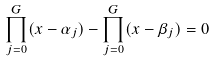Convert formula to latex. <formula><loc_0><loc_0><loc_500><loc_500>\prod _ { j = 0 } ^ { G } ( x - \alpha _ { j } ) - \prod _ { j = 0 } ^ { G } ( x - \beta _ { j } ) = 0</formula> 